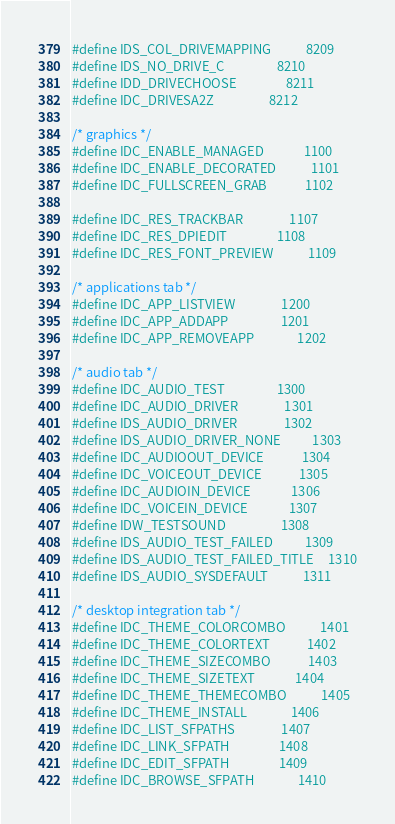Convert code to text. <code><loc_0><loc_0><loc_500><loc_500><_C_>#define IDS_COL_DRIVEMAPPING            8209
#define IDS_NO_DRIVE_C                  8210
#define IDD_DRIVECHOOSE                 8211
#define IDC_DRIVESA2Z                   8212

/* graphics */
#define IDC_ENABLE_MANAGED              1100
#define IDC_ENABLE_DECORATED            1101
#define IDC_FULLSCREEN_GRAB             1102

#define IDC_RES_TRACKBAR                1107
#define IDC_RES_DPIEDIT                 1108
#define IDC_RES_FONT_PREVIEW            1109

/* applications tab */
#define IDC_APP_LISTVIEW                1200
#define IDC_APP_ADDAPP                  1201
#define IDC_APP_REMOVEAPP               1202

/* audio tab */
#define IDC_AUDIO_TEST                  1300
#define IDC_AUDIO_DRIVER                1301
#define IDS_AUDIO_DRIVER                1302
#define IDS_AUDIO_DRIVER_NONE           1303
#define IDC_AUDIOOUT_DEVICE             1304
#define IDC_VOICEOUT_DEVICE             1305
#define IDC_AUDIOIN_DEVICE              1306
#define IDC_VOICEIN_DEVICE              1307
#define IDW_TESTSOUND                   1308
#define IDS_AUDIO_TEST_FAILED           1309
#define IDS_AUDIO_TEST_FAILED_TITLE     1310
#define IDS_AUDIO_SYSDEFAULT            1311

/* desktop integration tab */
#define IDC_THEME_COLORCOMBO            1401
#define IDC_THEME_COLORTEXT             1402
#define IDC_THEME_SIZECOMBO             1403
#define IDC_THEME_SIZETEXT              1404
#define IDC_THEME_THEMECOMBO            1405
#define IDC_THEME_INSTALL               1406
#define IDC_LIST_SFPATHS                1407
#define IDC_LINK_SFPATH                 1408
#define IDC_EDIT_SFPATH                 1409
#define IDC_BROWSE_SFPATH               1410</code> 